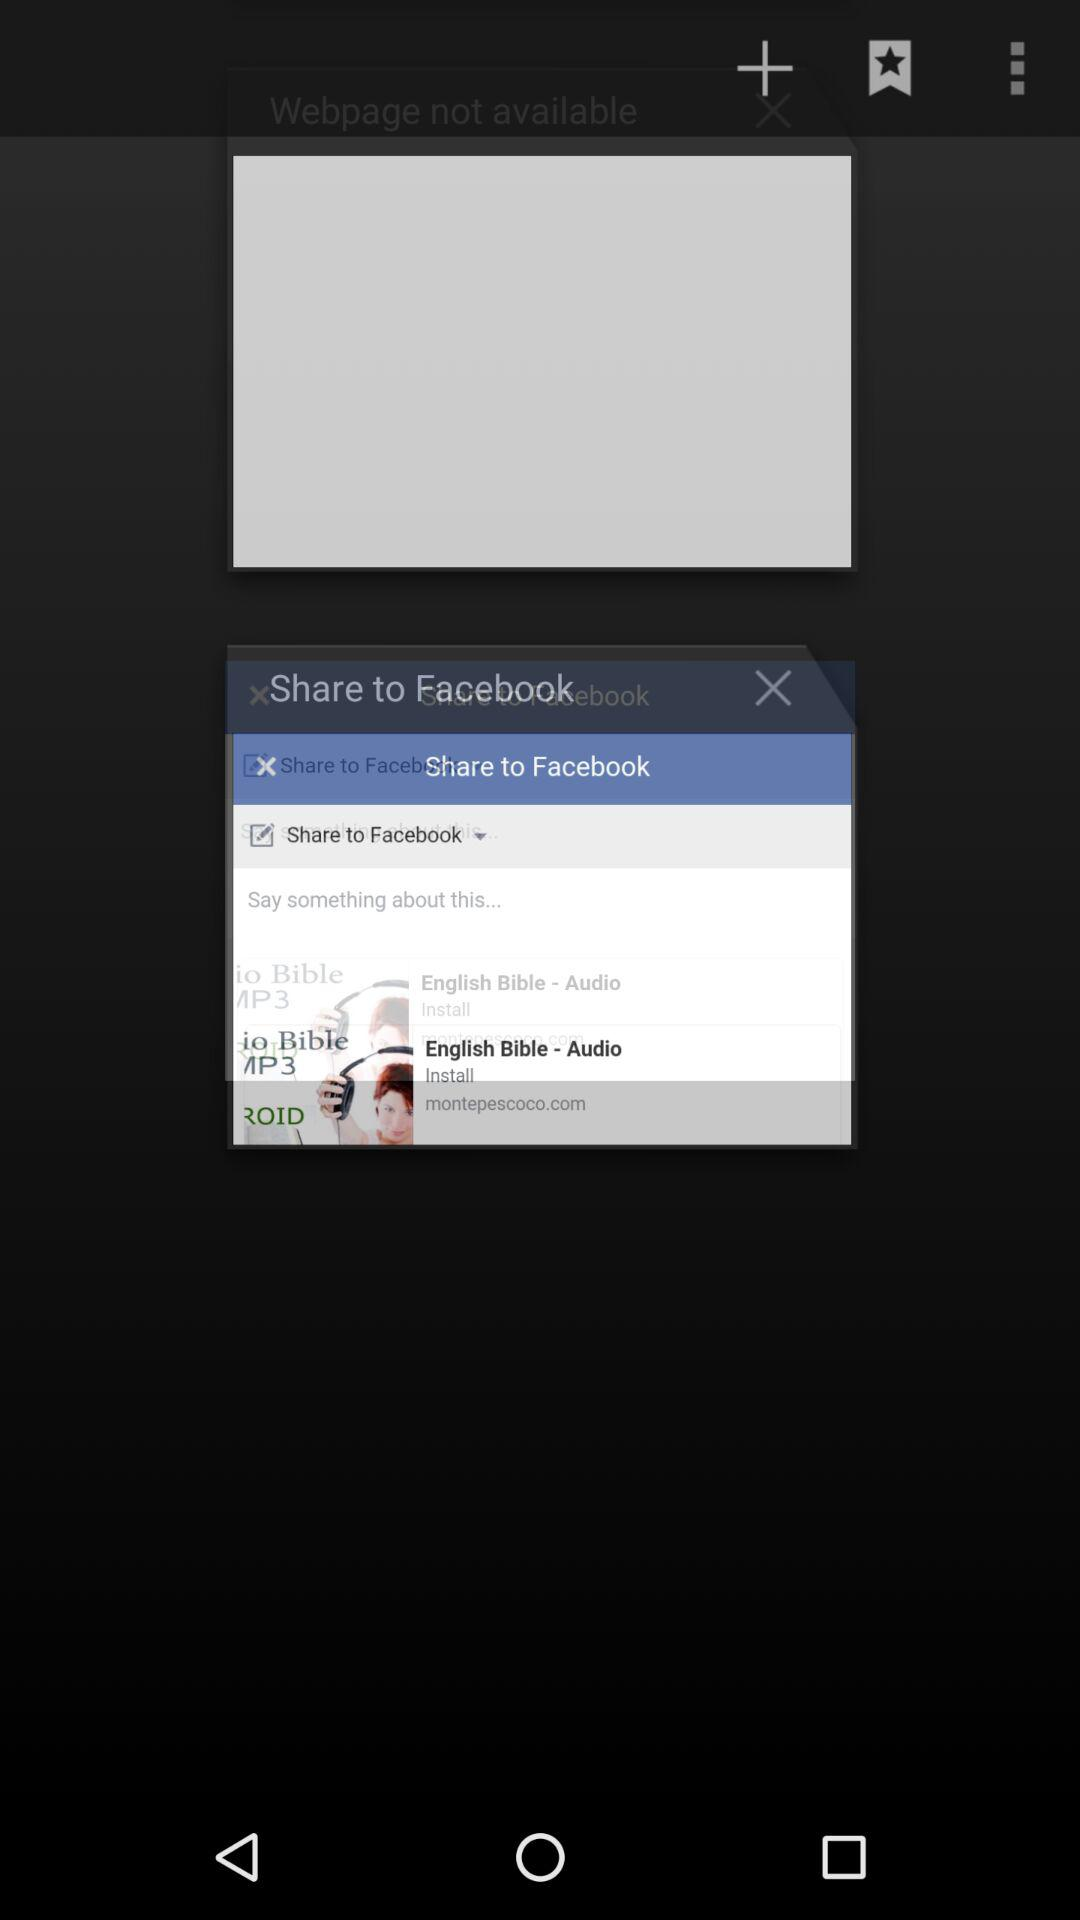What is the option to share? The option is "Facebook". 